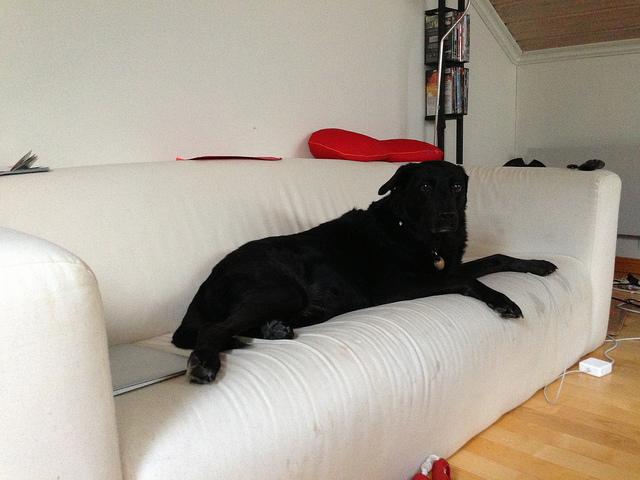What color is the dog?
Give a very brief answer. Black. Is the dog wearing a collar?
Concise answer only. Yes. Are the dog and the sofa the same color?
Quick response, please. No. 